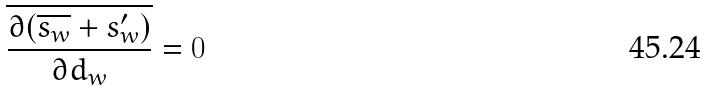Convert formula to latex. <formula><loc_0><loc_0><loc_500><loc_500>\overline { \frac { \partial ( \overline { s _ { w } } + s _ { w } ^ { \prime } ) } { \partial d _ { w } } } = 0</formula> 